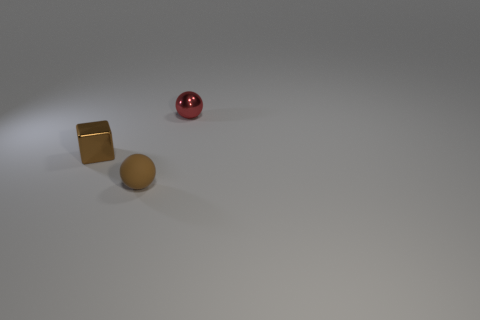Could the objects in the image serve any practical function? From the image alone, the objects appear to be more aesthetic or decorative rather than functional. They lack any apparent mechanisms or structures that would suggest a utilitarian purpose. However, without further context, it's not possible to determine if they serve a specific function beyond what is visually apparent. 